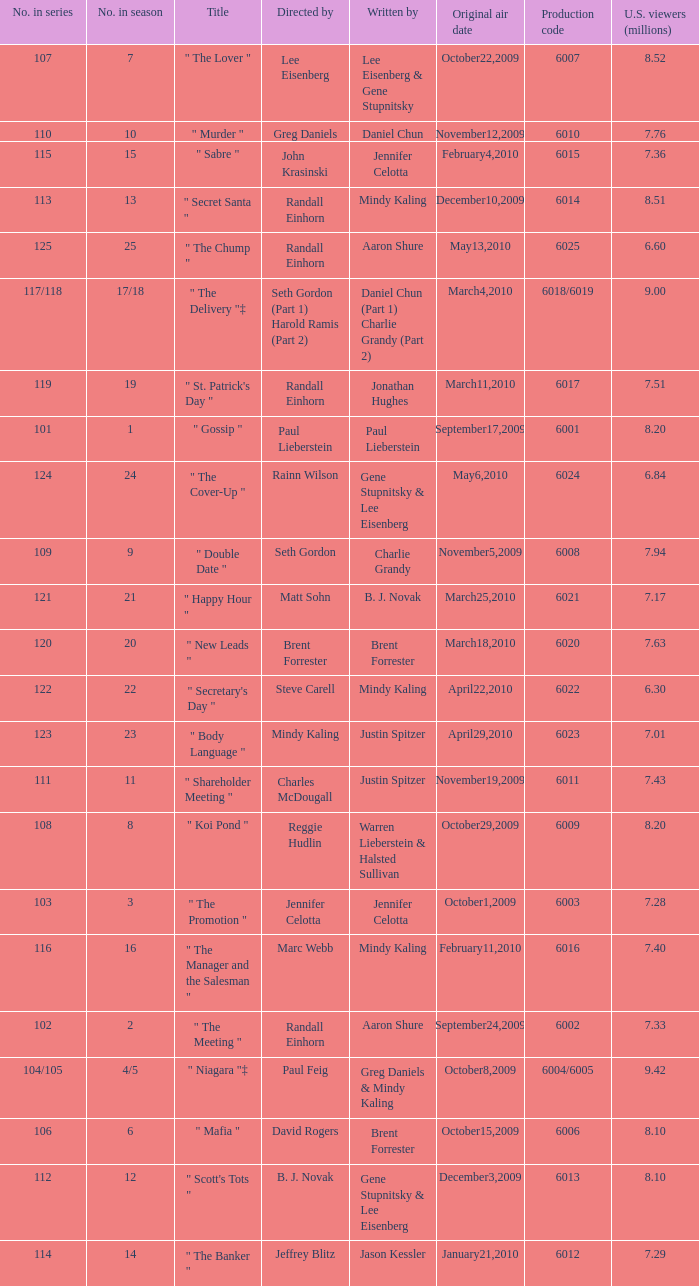Help me parse the entirety of this table. {'header': ['No. in series', 'No. in season', 'Title', 'Directed by', 'Written by', 'Original air date', 'Production code', 'U.S. viewers (millions)'], 'rows': [['107', '7', '" The Lover "', 'Lee Eisenberg', 'Lee Eisenberg & Gene Stupnitsky', 'October22,2009', '6007', '8.52'], ['110', '10', '" Murder "', 'Greg Daniels', 'Daniel Chun', 'November12,2009', '6010', '7.76'], ['115', '15', '" Sabre "', 'John Krasinski', 'Jennifer Celotta', 'February4,2010', '6015', '7.36'], ['113', '13', '" Secret Santa "', 'Randall Einhorn', 'Mindy Kaling', 'December10,2009', '6014', '8.51'], ['125', '25', '" The Chump "', 'Randall Einhorn', 'Aaron Shure', 'May13,2010', '6025', '6.60'], ['117/118', '17/18', '" The Delivery "‡', 'Seth Gordon (Part 1) Harold Ramis (Part 2)', 'Daniel Chun (Part 1) Charlie Grandy (Part 2)', 'March4,2010', '6018/6019', '9.00'], ['119', '19', '" St. Patrick\'s Day "', 'Randall Einhorn', 'Jonathan Hughes', 'March11,2010', '6017', '7.51'], ['101', '1', '" Gossip "', 'Paul Lieberstein', 'Paul Lieberstein', 'September17,2009', '6001', '8.20'], ['124', '24', '" The Cover-Up "', 'Rainn Wilson', 'Gene Stupnitsky & Lee Eisenberg', 'May6,2010', '6024', '6.84'], ['109', '9', '" Double Date "', 'Seth Gordon', 'Charlie Grandy', 'November5,2009', '6008', '7.94'], ['121', '21', '" Happy Hour "', 'Matt Sohn', 'B. J. Novak', 'March25,2010', '6021', '7.17'], ['120', '20', '" New Leads "', 'Brent Forrester', 'Brent Forrester', 'March18,2010', '6020', '7.63'], ['122', '22', '" Secretary\'s Day "', 'Steve Carell', 'Mindy Kaling', 'April22,2010', '6022', '6.30'], ['123', '23', '" Body Language "', 'Mindy Kaling', 'Justin Spitzer', 'April29,2010', '6023', '7.01'], ['111', '11', '" Shareholder Meeting "', 'Charles McDougall', 'Justin Spitzer', 'November19,2009', '6011', '7.43'], ['108', '8', '" Koi Pond "', 'Reggie Hudlin', 'Warren Lieberstein & Halsted Sullivan', 'October29,2009', '6009', '8.20'], ['103', '3', '" The Promotion "', 'Jennifer Celotta', 'Jennifer Celotta', 'October1,2009', '6003', '7.28'], ['116', '16', '" The Manager and the Salesman "', 'Marc Webb', 'Mindy Kaling', 'February11,2010', '6016', '7.40'], ['102', '2', '" The Meeting "', 'Randall Einhorn', 'Aaron Shure', 'September24,2009', '6002', '7.33'], ['104/105', '4/5', '" Niagara "‡', 'Paul Feig', 'Greg Daniels & Mindy Kaling', 'October8,2009', '6004/6005', '9.42'], ['106', '6', '" Mafia "', 'David Rogers', 'Brent Forrester', 'October15,2009', '6006', '8.10'], ['112', '12', '" Scott\'s Tots "', 'B. J. Novak', 'Gene Stupnitsky & Lee Eisenberg', 'December3,2009', '6013', '8.10'], ['114', '14', '" The Banker "', 'Jeffrey Blitz', 'Jason Kessler', 'January21,2010', '6012', '7.29']]} Name the production code by paul lieberstein 6001.0. 